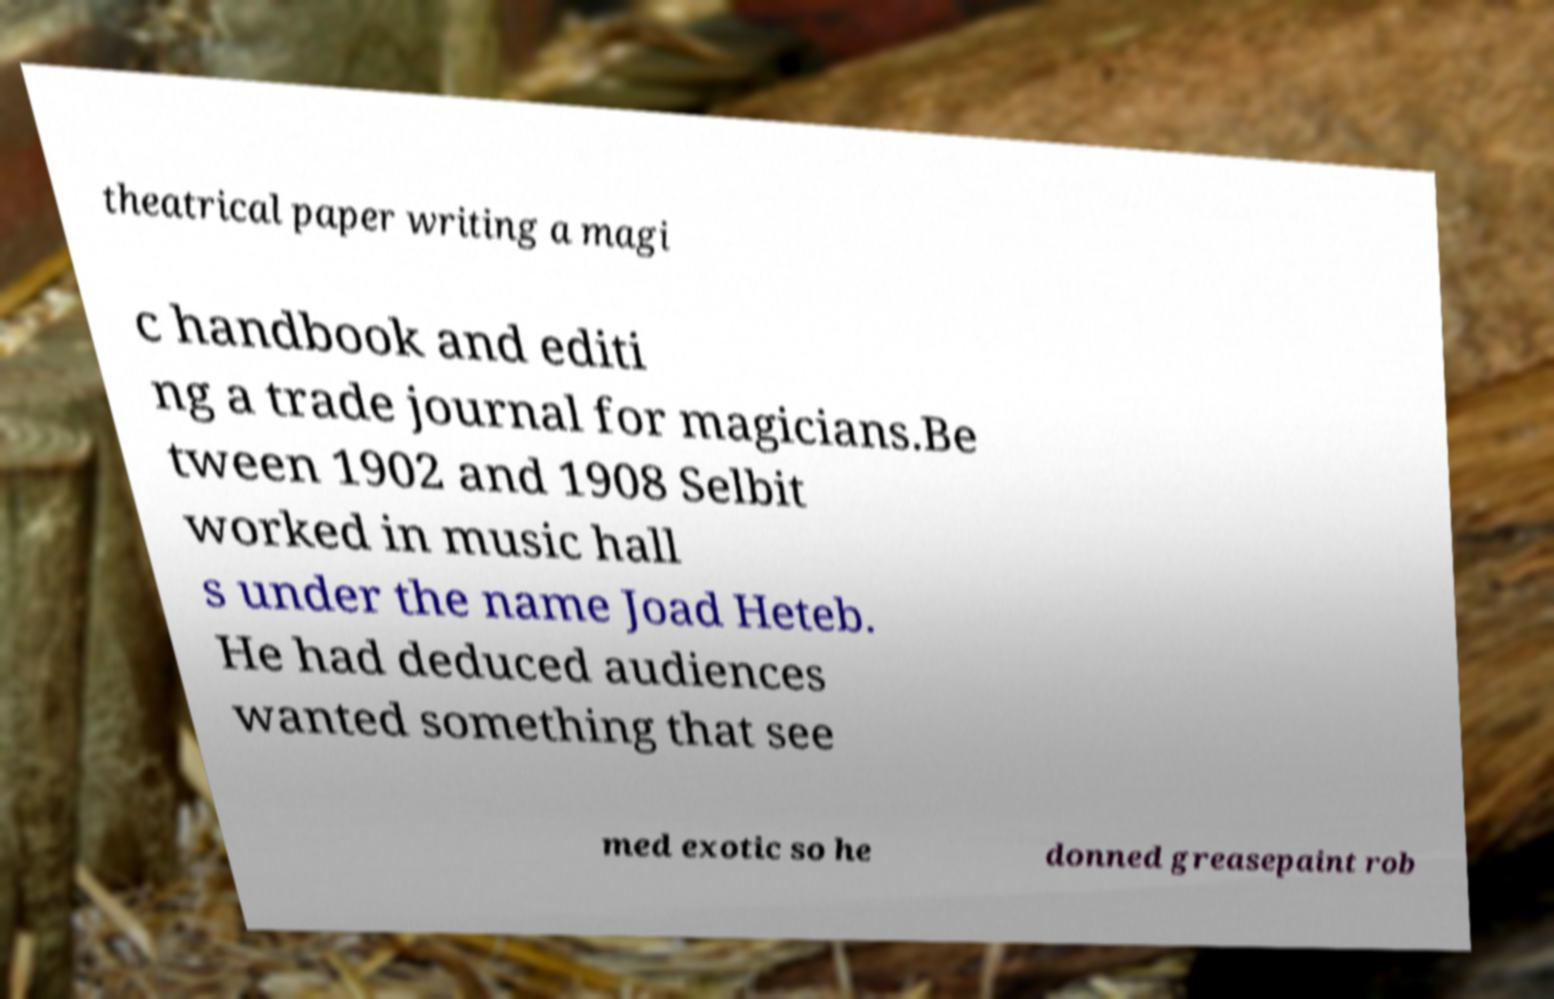There's text embedded in this image that I need extracted. Can you transcribe it verbatim? theatrical paper writing a magi c handbook and editi ng a trade journal for magicians.Be tween 1902 and 1908 Selbit worked in music hall s under the name Joad Heteb. He had deduced audiences wanted something that see med exotic so he donned greasepaint rob 